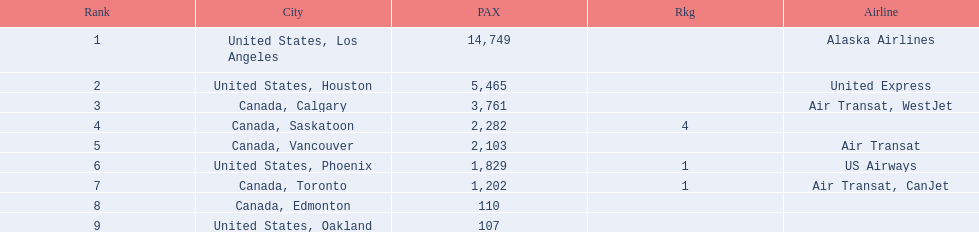What numbers are in the passengers column? 14,749, 5,465, 3,761, 2,282, 2,103, 1,829, 1,202, 110, 107. Which number is the lowest number in the passengers column? 107. What city is associated with this number? United States, Oakland. 